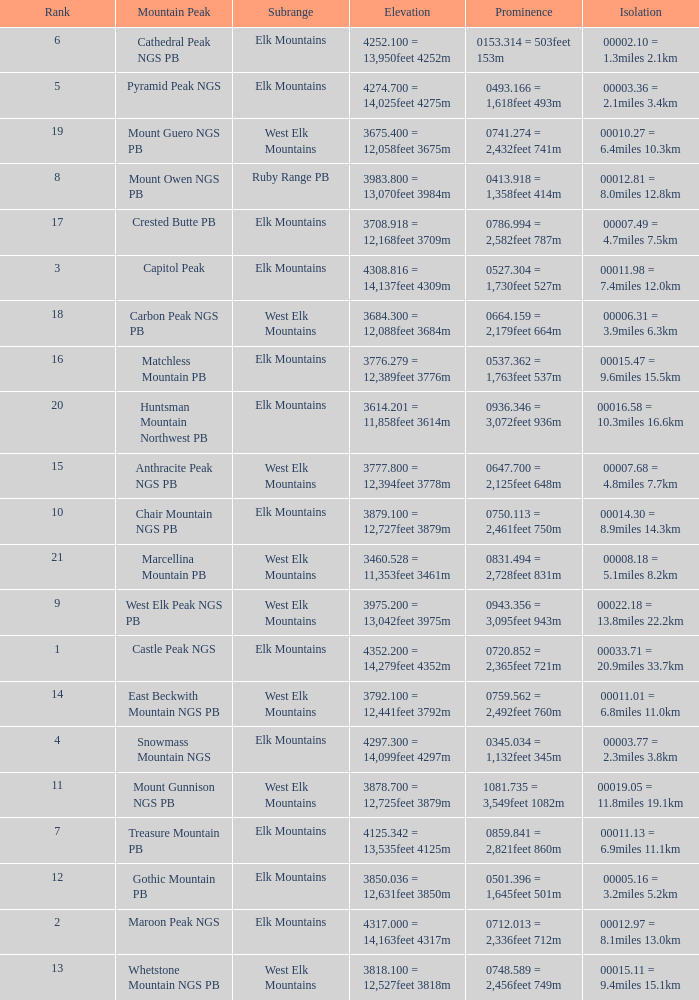Name the Rank of Rank Mountain Peak of crested butte pb? 17.0. 